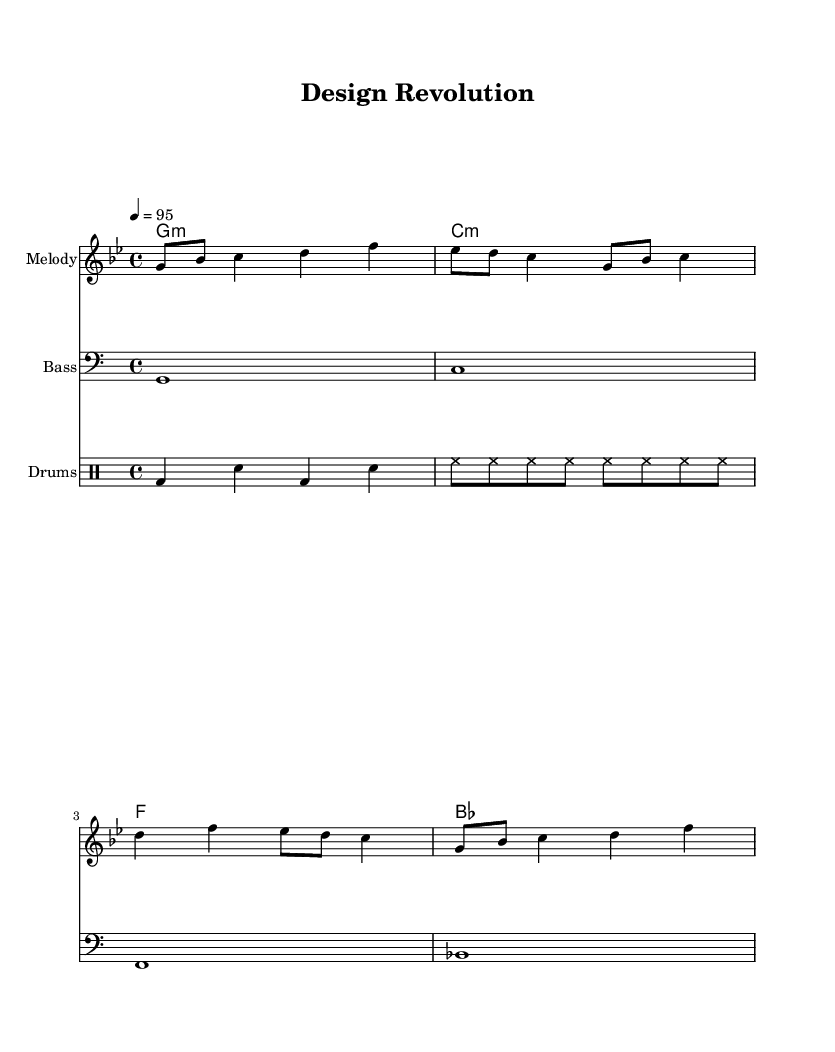What is the key signature of this music? The key signature is indicated at the beginning of the staff and contains a flat symbol, specifying G minor, which has two flats (B♭ and E♭).
Answer: G minor What is the time signature of this composition? The time signature is shown as 4/4 at the beginning of the music, which means there are four beats in each measure and a quarter note gets one beat.
Answer: 4/4 What is the indicated tempo of the piece? The tempo marking at the beginning specifies a speed of 95 beats per minute, indicating how fast the music should be played.
Answer: 95 How many measures are in the melody? By counting the segments separated by vertical lines in the melody section, we find that there are a total of four measures represented in the notation.
Answer: 4 What type of drum pattern is used in this rap composition? The drum part shows a bass drum (bd) and snare (sn) alternating in a straightforward rhythmic pattern, typical of rap music, enhancing the groove while providing a steady backbeat.
Answer: Bass and snare What chords are included in this rap piece? By examining the chord names underneath the staff, we note they are G minor, C minor, F major, and B♭ major, completing a typical progression used in rap tracks to support the melody.
Answer: G minor, C minor, F major, B♭ major What is the overall mood conveyed by the upbeat tempo and harmony? The combination of an upbeat tempo of 95 and the harmonically rich chords conveys an energetic and positive vibe, typical for celebrating creativity and ingenuity in industrial design.
Answer: Energetic and positive 